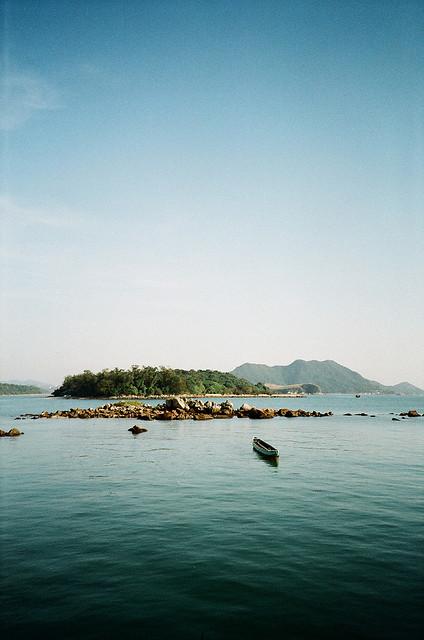Does the water look clean?
Concise answer only. Yes. How is the sky?
Short answer required. Clear. What time of day is it?
Be succinct. Afternoon. What is in the background?
Be succinct. Island. What is being flown?
Answer briefly. Nothing. Is the sky blue?
Quick response, please. Yes. Are there rocks in the water?
Keep it brief. Yes. How much water there?
Keep it brief. Lot. Who is on the beach?
Quick response, please. No one. What type of seafood are these boats designed to catch?
Give a very brief answer. Fish. Is this a sunrise or sunset?
Give a very brief answer. Sunrise. 